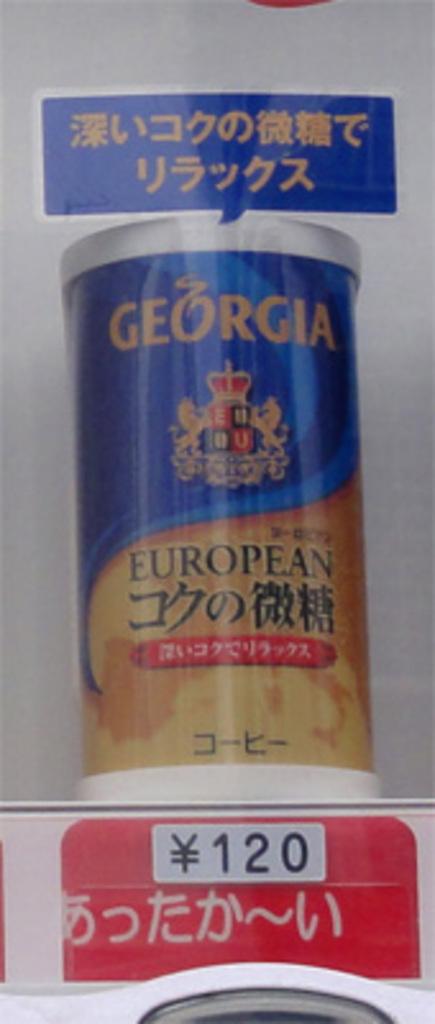How much is this?
Offer a terse response. 120. What state is on the front of the can?
Your answer should be very brief. Georgia. 